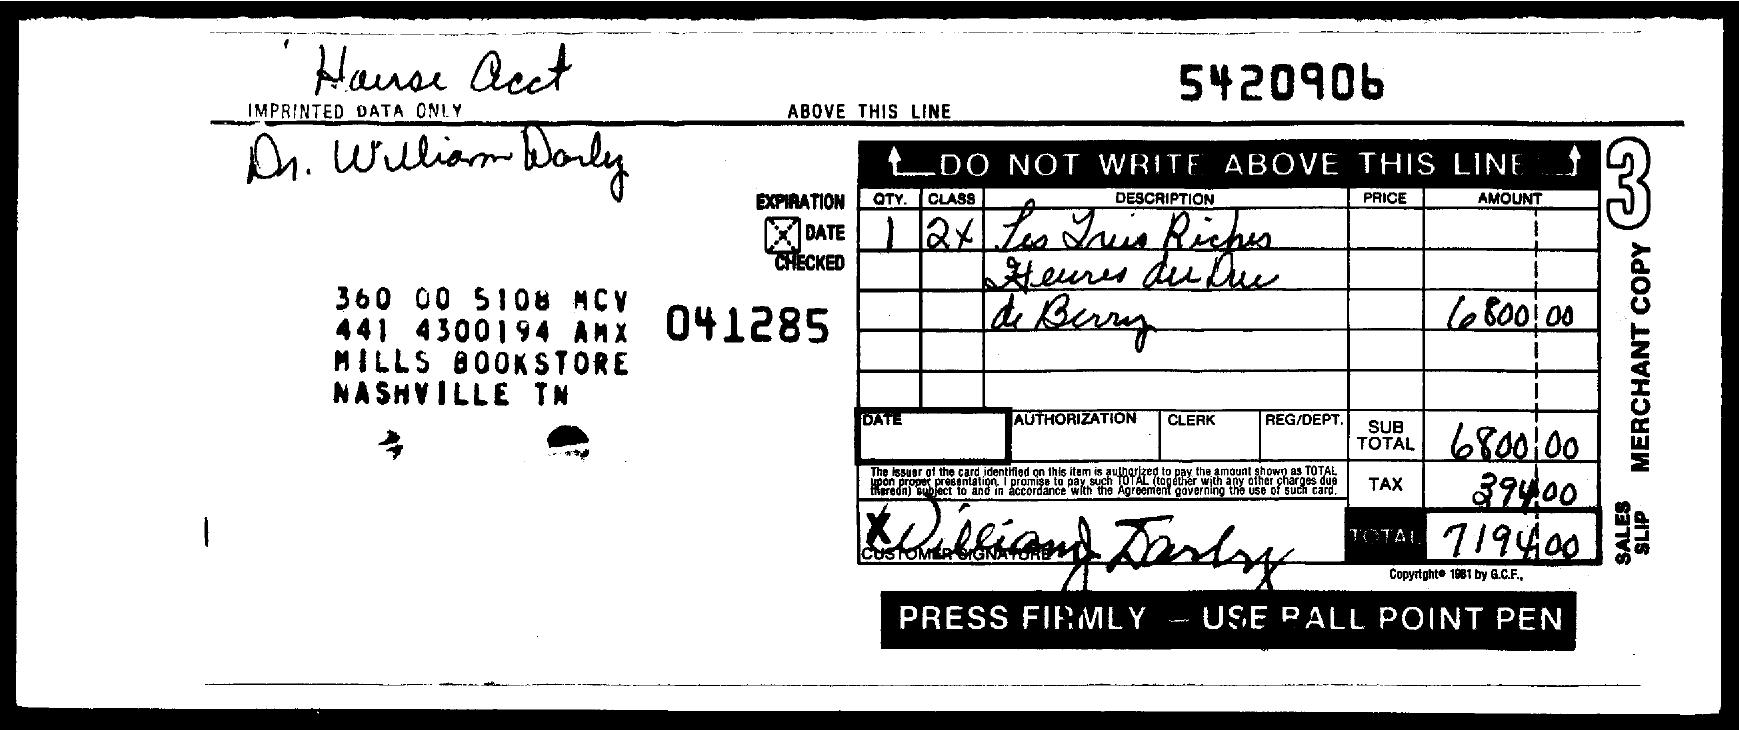What is the number at the top of the document?
Give a very brief answer. 5420906. 